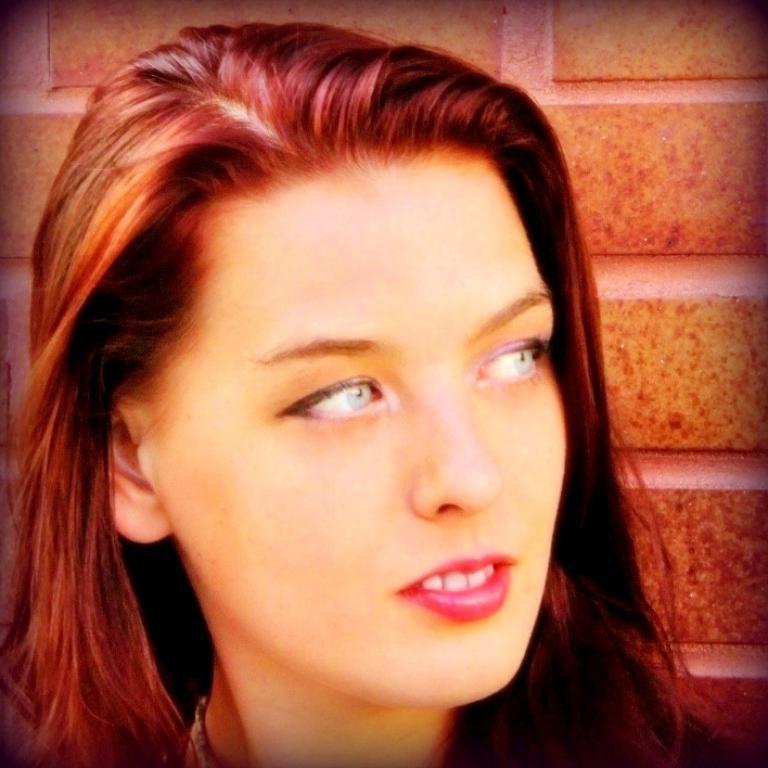Describe this image in one or two sentences. There is a woman watching something and smiling. In the background, there is wall. 